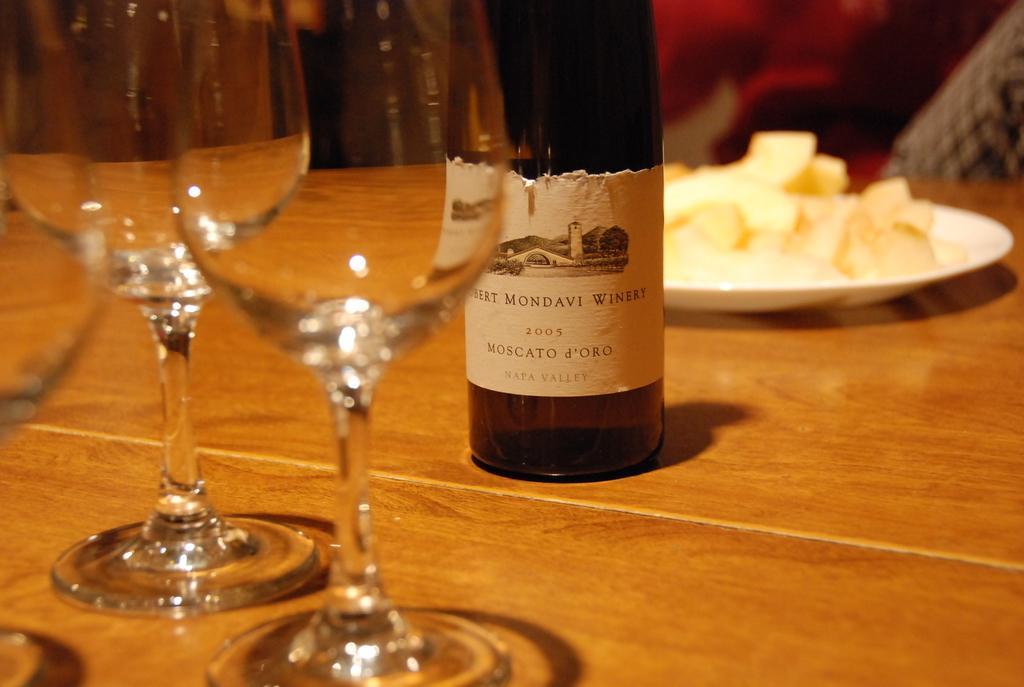Please provide a concise description of this image. In this Image I see few glasses, a bottle and a plate of food which are placed on a table. 